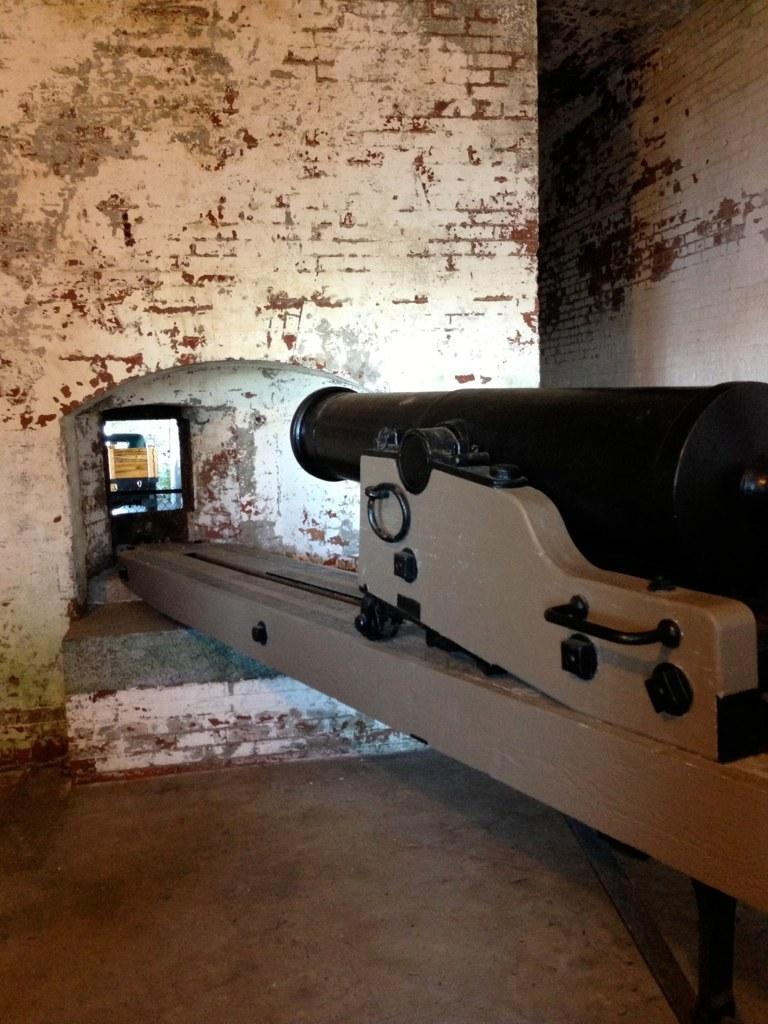What is the main subject in the image? There is a machine in the image. What type of structure can be seen in the image? There is a tunnel in the image. What surrounds the machine and tunnel in the image? There are walls in the image. How many hens are laying eggs in the image? There are no hens or eggs present in the image. What type of produce is being grown in the image? There is no produce being grown in the image. 